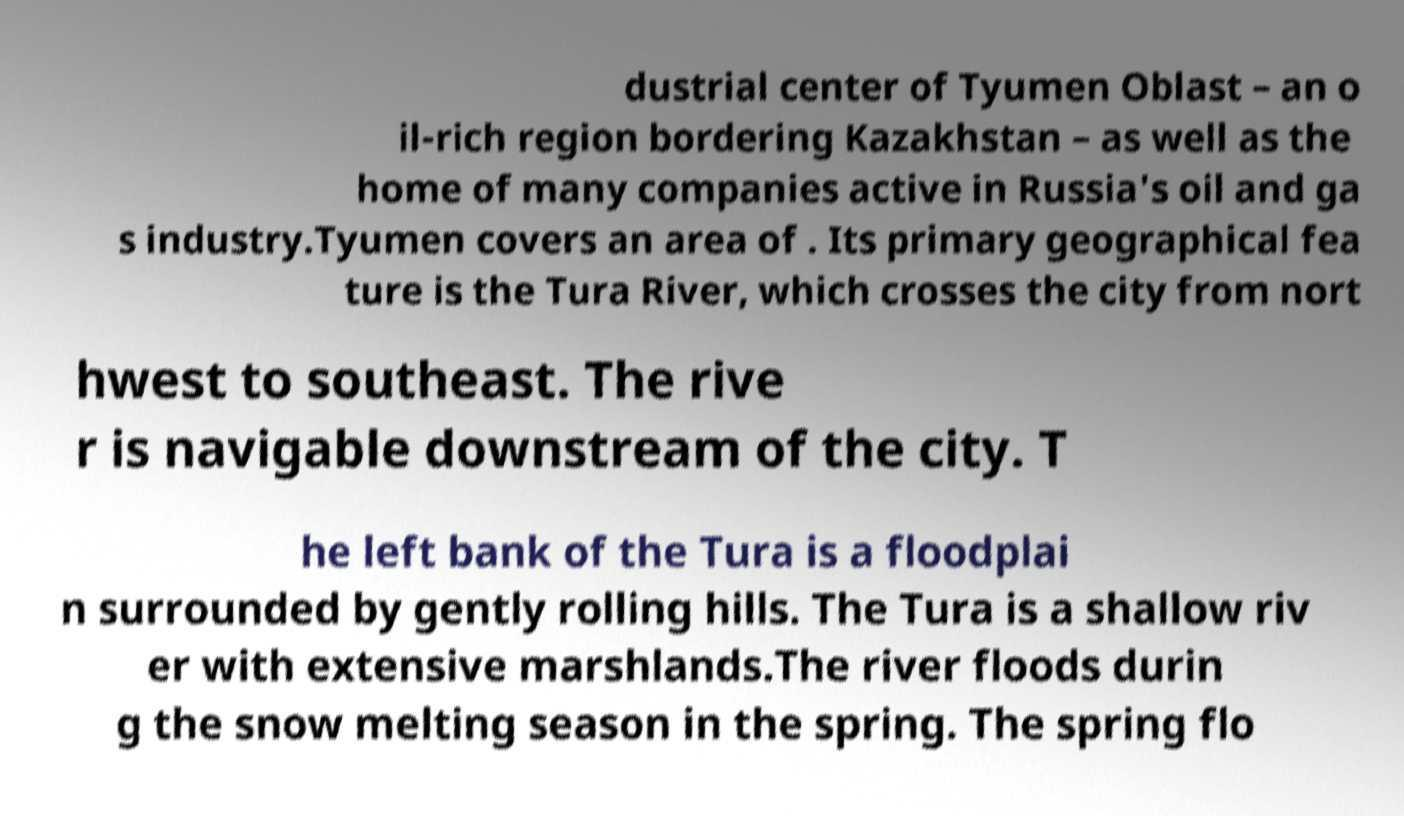Please read and relay the text visible in this image. What does it say? dustrial center of Tyumen Oblast – an o il-rich region bordering Kazakhstan – as well as the home of many companies active in Russia's oil and ga s industry.Tyumen covers an area of . Its primary geographical fea ture is the Tura River, which crosses the city from nort hwest to southeast. The rive r is navigable downstream of the city. T he left bank of the Tura is a floodplai n surrounded by gently rolling hills. The Tura is a shallow riv er with extensive marshlands.The river floods durin g the snow melting season in the spring. The spring flo 